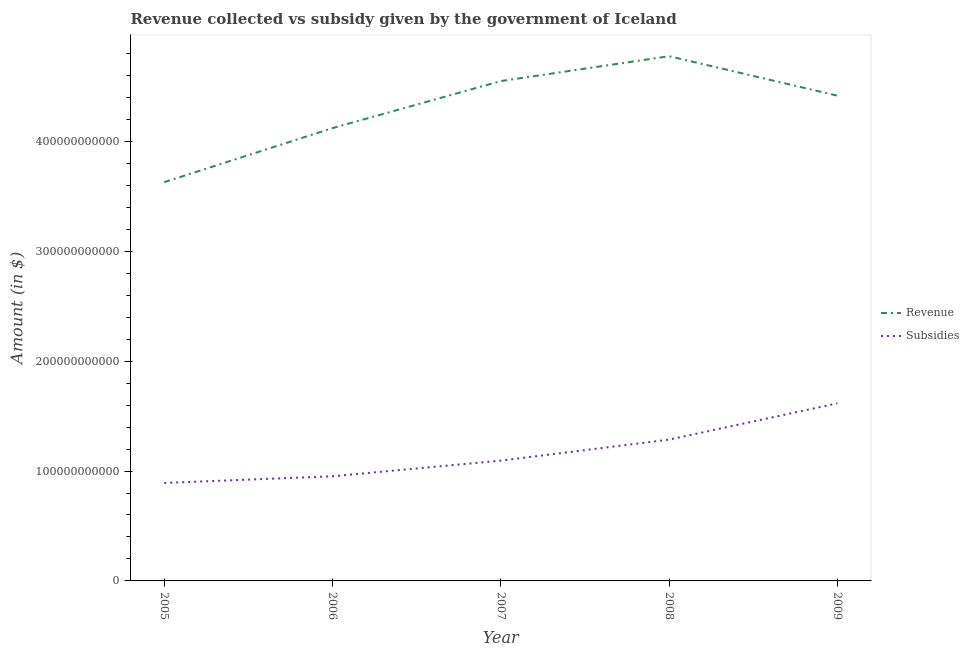How many different coloured lines are there?
Provide a short and direct response. 2. What is the amount of subsidies given in 2009?
Give a very brief answer. 1.62e+11. Across all years, what is the maximum amount of revenue collected?
Provide a succinct answer. 4.77e+11. Across all years, what is the minimum amount of subsidies given?
Provide a short and direct response. 8.92e+1. In which year was the amount of subsidies given minimum?
Offer a very short reply. 2005. What is the total amount of revenue collected in the graph?
Give a very brief answer. 2.15e+12. What is the difference between the amount of revenue collected in 2007 and that in 2008?
Provide a short and direct response. -2.26e+1. What is the difference between the amount of revenue collected in 2005 and the amount of subsidies given in 2008?
Your response must be concise. 2.34e+11. What is the average amount of revenue collected per year?
Your answer should be compact. 4.30e+11. In the year 2007, what is the difference between the amount of subsidies given and amount of revenue collected?
Give a very brief answer. -3.45e+11. In how many years, is the amount of revenue collected greater than 40000000000 $?
Offer a very short reply. 5. What is the ratio of the amount of subsidies given in 2006 to that in 2007?
Provide a short and direct response. 0.87. Is the amount of subsidies given in 2006 less than that in 2009?
Provide a succinct answer. Yes. Is the difference between the amount of subsidies given in 2006 and 2008 greater than the difference between the amount of revenue collected in 2006 and 2008?
Provide a short and direct response. Yes. What is the difference between the highest and the second highest amount of subsidies given?
Your response must be concise. 3.30e+1. What is the difference between the highest and the lowest amount of subsidies given?
Offer a very short reply. 7.24e+1. Is the amount of revenue collected strictly less than the amount of subsidies given over the years?
Make the answer very short. No. How many lines are there?
Offer a terse response. 2. How many years are there in the graph?
Your answer should be very brief. 5. What is the difference between two consecutive major ticks on the Y-axis?
Offer a very short reply. 1.00e+11. Does the graph contain grids?
Offer a very short reply. No. Where does the legend appear in the graph?
Give a very brief answer. Center right. What is the title of the graph?
Provide a succinct answer. Revenue collected vs subsidy given by the government of Iceland. What is the label or title of the X-axis?
Your response must be concise. Year. What is the label or title of the Y-axis?
Keep it short and to the point. Amount (in $). What is the Amount (in $) of Revenue in 2005?
Give a very brief answer. 3.63e+11. What is the Amount (in $) of Subsidies in 2005?
Your answer should be compact. 8.92e+1. What is the Amount (in $) in Revenue in 2006?
Provide a succinct answer. 4.12e+11. What is the Amount (in $) of Subsidies in 2006?
Provide a succinct answer. 9.52e+1. What is the Amount (in $) in Revenue in 2007?
Make the answer very short. 4.55e+11. What is the Amount (in $) in Subsidies in 2007?
Ensure brevity in your answer.  1.09e+11. What is the Amount (in $) of Revenue in 2008?
Offer a very short reply. 4.77e+11. What is the Amount (in $) in Subsidies in 2008?
Make the answer very short. 1.29e+11. What is the Amount (in $) of Revenue in 2009?
Give a very brief answer. 4.42e+11. What is the Amount (in $) of Subsidies in 2009?
Keep it short and to the point. 1.62e+11. Across all years, what is the maximum Amount (in $) of Revenue?
Offer a terse response. 4.77e+11. Across all years, what is the maximum Amount (in $) of Subsidies?
Give a very brief answer. 1.62e+11. Across all years, what is the minimum Amount (in $) of Revenue?
Offer a very short reply. 3.63e+11. Across all years, what is the minimum Amount (in $) in Subsidies?
Make the answer very short. 8.92e+1. What is the total Amount (in $) in Revenue in the graph?
Offer a very short reply. 2.15e+12. What is the total Amount (in $) of Subsidies in the graph?
Provide a short and direct response. 5.84e+11. What is the difference between the Amount (in $) in Revenue in 2005 and that in 2006?
Your answer should be compact. -4.92e+1. What is the difference between the Amount (in $) of Subsidies in 2005 and that in 2006?
Provide a succinct answer. -6.07e+09. What is the difference between the Amount (in $) of Revenue in 2005 and that in 2007?
Ensure brevity in your answer.  -9.20e+1. What is the difference between the Amount (in $) in Subsidies in 2005 and that in 2007?
Provide a short and direct response. -2.03e+1. What is the difference between the Amount (in $) of Revenue in 2005 and that in 2008?
Your answer should be compact. -1.15e+11. What is the difference between the Amount (in $) in Subsidies in 2005 and that in 2008?
Your answer should be very brief. -3.94e+1. What is the difference between the Amount (in $) in Revenue in 2005 and that in 2009?
Provide a short and direct response. -7.87e+1. What is the difference between the Amount (in $) of Subsidies in 2005 and that in 2009?
Your response must be concise. -7.24e+1. What is the difference between the Amount (in $) of Revenue in 2006 and that in 2007?
Provide a short and direct response. -4.28e+1. What is the difference between the Amount (in $) in Subsidies in 2006 and that in 2007?
Give a very brief answer. -1.42e+1. What is the difference between the Amount (in $) of Revenue in 2006 and that in 2008?
Make the answer very short. -6.54e+1. What is the difference between the Amount (in $) in Subsidies in 2006 and that in 2008?
Provide a succinct answer. -3.34e+1. What is the difference between the Amount (in $) in Revenue in 2006 and that in 2009?
Give a very brief answer. -2.95e+1. What is the difference between the Amount (in $) in Subsidies in 2006 and that in 2009?
Ensure brevity in your answer.  -6.64e+1. What is the difference between the Amount (in $) in Revenue in 2007 and that in 2008?
Provide a succinct answer. -2.26e+1. What is the difference between the Amount (in $) in Subsidies in 2007 and that in 2008?
Provide a short and direct response. -1.91e+1. What is the difference between the Amount (in $) of Revenue in 2007 and that in 2009?
Your answer should be very brief. 1.32e+1. What is the difference between the Amount (in $) in Subsidies in 2007 and that in 2009?
Keep it short and to the point. -5.21e+1. What is the difference between the Amount (in $) in Revenue in 2008 and that in 2009?
Ensure brevity in your answer.  3.59e+1. What is the difference between the Amount (in $) of Subsidies in 2008 and that in 2009?
Give a very brief answer. -3.30e+1. What is the difference between the Amount (in $) of Revenue in 2005 and the Amount (in $) of Subsidies in 2006?
Your answer should be very brief. 2.68e+11. What is the difference between the Amount (in $) of Revenue in 2005 and the Amount (in $) of Subsidies in 2007?
Offer a terse response. 2.53e+11. What is the difference between the Amount (in $) of Revenue in 2005 and the Amount (in $) of Subsidies in 2008?
Your answer should be very brief. 2.34e+11. What is the difference between the Amount (in $) of Revenue in 2005 and the Amount (in $) of Subsidies in 2009?
Make the answer very short. 2.01e+11. What is the difference between the Amount (in $) of Revenue in 2006 and the Amount (in $) of Subsidies in 2007?
Your response must be concise. 3.03e+11. What is the difference between the Amount (in $) of Revenue in 2006 and the Amount (in $) of Subsidies in 2008?
Your answer should be compact. 2.83e+11. What is the difference between the Amount (in $) of Revenue in 2006 and the Amount (in $) of Subsidies in 2009?
Your response must be concise. 2.50e+11. What is the difference between the Amount (in $) in Revenue in 2007 and the Amount (in $) in Subsidies in 2008?
Provide a succinct answer. 3.26e+11. What is the difference between the Amount (in $) in Revenue in 2007 and the Amount (in $) in Subsidies in 2009?
Keep it short and to the point. 2.93e+11. What is the difference between the Amount (in $) in Revenue in 2008 and the Amount (in $) in Subsidies in 2009?
Make the answer very short. 3.16e+11. What is the average Amount (in $) of Revenue per year?
Provide a short and direct response. 4.30e+11. What is the average Amount (in $) of Subsidies per year?
Ensure brevity in your answer.  1.17e+11. In the year 2005, what is the difference between the Amount (in $) of Revenue and Amount (in $) of Subsidies?
Offer a very short reply. 2.74e+11. In the year 2006, what is the difference between the Amount (in $) in Revenue and Amount (in $) in Subsidies?
Your response must be concise. 3.17e+11. In the year 2007, what is the difference between the Amount (in $) of Revenue and Amount (in $) of Subsidies?
Give a very brief answer. 3.45e+11. In the year 2008, what is the difference between the Amount (in $) of Revenue and Amount (in $) of Subsidies?
Make the answer very short. 3.49e+11. In the year 2009, what is the difference between the Amount (in $) of Revenue and Amount (in $) of Subsidies?
Give a very brief answer. 2.80e+11. What is the ratio of the Amount (in $) in Revenue in 2005 to that in 2006?
Keep it short and to the point. 0.88. What is the ratio of the Amount (in $) of Subsidies in 2005 to that in 2006?
Offer a terse response. 0.94. What is the ratio of the Amount (in $) of Revenue in 2005 to that in 2007?
Provide a succinct answer. 0.8. What is the ratio of the Amount (in $) in Subsidies in 2005 to that in 2007?
Your response must be concise. 0.81. What is the ratio of the Amount (in $) in Revenue in 2005 to that in 2008?
Make the answer very short. 0.76. What is the ratio of the Amount (in $) of Subsidies in 2005 to that in 2008?
Make the answer very short. 0.69. What is the ratio of the Amount (in $) of Revenue in 2005 to that in 2009?
Ensure brevity in your answer.  0.82. What is the ratio of the Amount (in $) of Subsidies in 2005 to that in 2009?
Offer a very short reply. 0.55. What is the ratio of the Amount (in $) in Revenue in 2006 to that in 2007?
Give a very brief answer. 0.91. What is the ratio of the Amount (in $) of Subsidies in 2006 to that in 2007?
Your response must be concise. 0.87. What is the ratio of the Amount (in $) of Revenue in 2006 to that in 2008?
Give a very brief answer. 0.86. What is the ratio of the Amount (in $) in Subsidies in 2006 to that in 2008?
Offer a very short reply. 0.74. What is the ratio of the Amount (in $) in Revenue in 2006 to that in 2009?
Provide a short and direct response. 0.93. What is the ratio of the Amount (in $) in Subsidies in 2006 to that in 2009?
Provide a succinct answer. 0.59. What is the ratio of the Amount (in $) of Revenue in 2007 to that in 2008?
Keep it short and to the point. 0.95. What is the ratio of the Amount (in $) in Subsidies in 2007 to that in 2008?
Make the answer very short. 0.85. What is the ratio of the Amount (in $) in Subsidies in 2007 to that in 2009?
Provide a short and direct response. 0.68. What is the ratio of the Amount (in $) of Revenue in 2008 to that in 2009?
Give a very brief answer. 1.08. What is the ratio of the Amount (in $) in Subsidies in 2008 to that in 2009?
Your answer should be compact. 0.8. What is the difference between the highest and the second highest Amount (in $) in Revenue?
Ensure brevity in your answer.  2.26e+1. What is the difference between the highest and the second highest Amount (in $) of Subsidies?
Your answer should be compact. 3.30e+1. What is the difference between the highest and the lowest Amount (in $) in Revenue?
Make the answer very short. 1.15e+11. What is the difference between the highest and the lowest Amount (in $) in Subsidies?
Offer a terse response. 7.24e+1. 